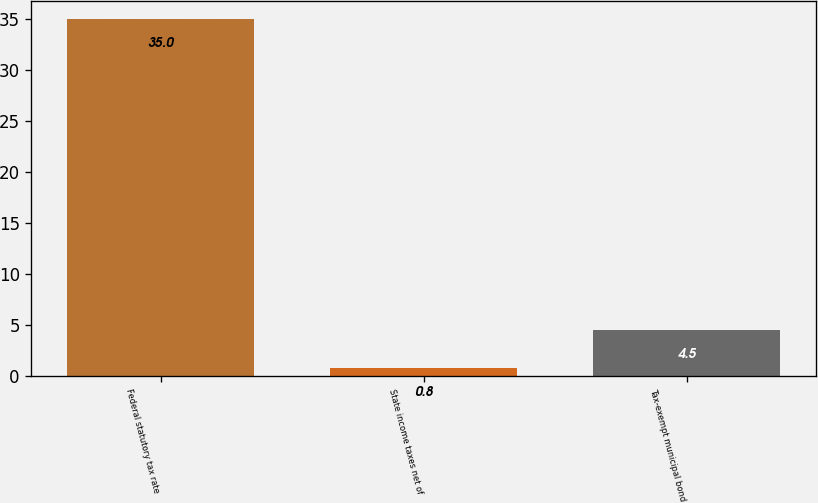<chart> <loc_0><loc_0><loc_500><loc_500><bar_chart><fcel>Federal statutory tax rate<fcel>State income taxes net of<fcel>Tax-exempt municipal bond<nl><fcel>35<fcel>0.8<fcel>4.5<nl></chart> 